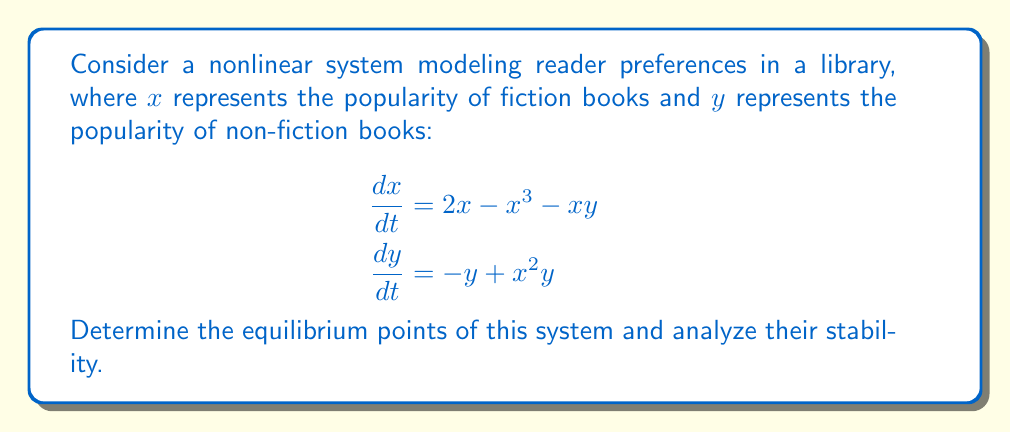Provide a solution to this math problem. 1. Find the equilibrium points by setting $\frac{dx}{dt} = 0$ and $\frac{dy}{dt} = 0$:

   $$\begin{aligned}
   2x - x^3 - xy &= 0 \\
   -y + x^2y &= 0
   \end{aligned}$$

2. From the second equation, either $y = 0$ or $x^2 = 1$.

3. If $y = 0$, substitute into the first equation:
   $2x - x^3 = 0$
   $x(2 - x^2) = 0$
   So, $x = 0$ or $x = \pm\sqrt{2}$

4. If $x^2 = 1$, then $x = \pm 1$. Substitute into the first equation:
   $2(\pm 1) - (\pm 1)^3 - (\pm 1)y = 0$
   $\pm 2 - (\pm 1) - (\pm 1)y = 0$
   $y = \pm 1$

5. The equilibrium points are: $(0,0)$, $(\sqrt{2},0)$, $(-\sqrt{2},0)$, $(1,1)$, and $(-1,-1)$.

6. To analyze stability, compute the Jacobian matrix:
   $$J = \begin{bmatrix}
   2 - 3x^2 - y & -x \\
   2xy & -1 + x^2
   \end{bmatrix}$$

7. Evaluate $J$ at each equilibrium point and find eigenvalues:

   a) At $(0,0)$:
      $$J_{(0,0)} = \begin{bmatrix}
      2 & 0 \\
      0 & -1
      \end{bmatrix}$$
      Eigenvalues: $\lambda_1 = 2$, $\lambda_2 = -1$
      Unstable saddle point

   b) At $(\sqrt{2},0)$ and $(-\sqrt{2},0)$:
      $$J_{(\pm\sqrt{2},0)} = \begin{bmatrix}
      -4 & \mp\sqrt{2} \\
      0 & 1
      \end{bmatrix}$$
      Eigenvalues: $\lambda_1 = -4$, $\lambda_2 = 1$
      Unstable saddle points

   c) At $(1,1)$ and $(-1,-1)$:
      $$J_{(\pm1,\pm1)} = \begin{bmatrix}
      -2 & \mp1 \\
      \pm2 & 0
      \end{bmatrix}$$
      Eigenvalues: $\lambda_{1,2} = -1 \pm i\sqrt{3}$
      Stable spiral points

8. Conclusion: $(0,0)$, $(\sqrt{2},0)$, and $(-\sqrt{2},0)$ are unstable equilibrium points, while $(1,1)$ and $(-1,-1)$ are stable equilibrium points.
Answer: $(0,0)$, $(\sqrt{2},0)$, $(-\sqrt{2},0)$ unstable; $(1,1)$, $(-1,-1)$ stable. 